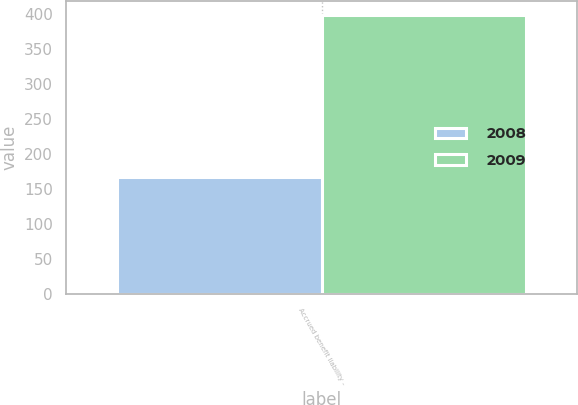Convert chart to OTSL. <chart><loc_0><loc_0><loc_500><loc_500><stacked_bar_chart><ecel><fcel>Accrued benefit liability -<nl><fcel>2008<fcel>167<nl><fcel>2009<fcel>399<nl></chart> 